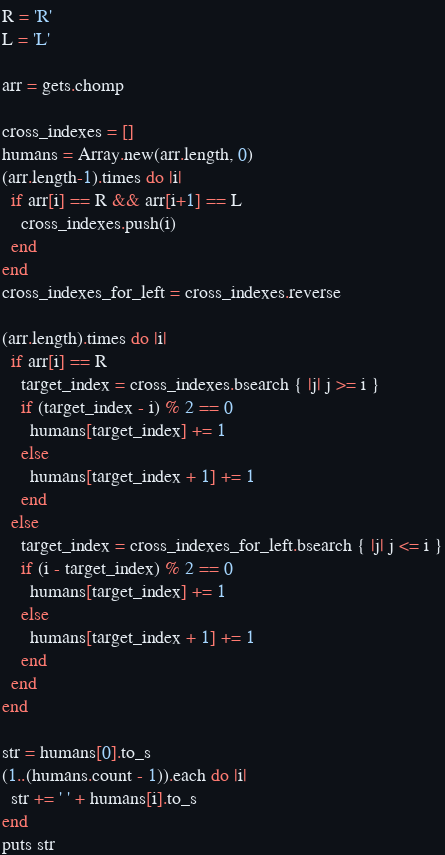<code> <loc_0><loc_0><loc_500><loc_500><_Ruby_>R = 'R'
L = 'L'

arr = gets.chomp

cross_indexes = []
humans = Array.new(arr.length, 0)
(arr.length-1).times do |i|
  if arr[i] == R && arr[i+1] == L
    cross_indexes.push(i)
  end
end
cross_indexes_for_left = cross_indexes.reverse

(arr.length).times do |i|
  if arr[i] == R
    target_index = cross_indexes.bsearch { |j| j >= i }
    if (target_index - i) % 2 == 0
      humans[target_index] += 1
    else
      humans[target_index + 1] += 1
    end
  else
    target_index = cross_indexes_for_left.bsearch { |j| j <= i }
    if (i - target_index) % 2 == 0
      humans[target_index] += 1
    else
      humans[target_index + 1] += 1
    end
  end
end

str = humans[0].to_s
(1..(humans.count - 1)).each do |i|
  str += ' ' + humans[i].to_s
end
puts str</code> 